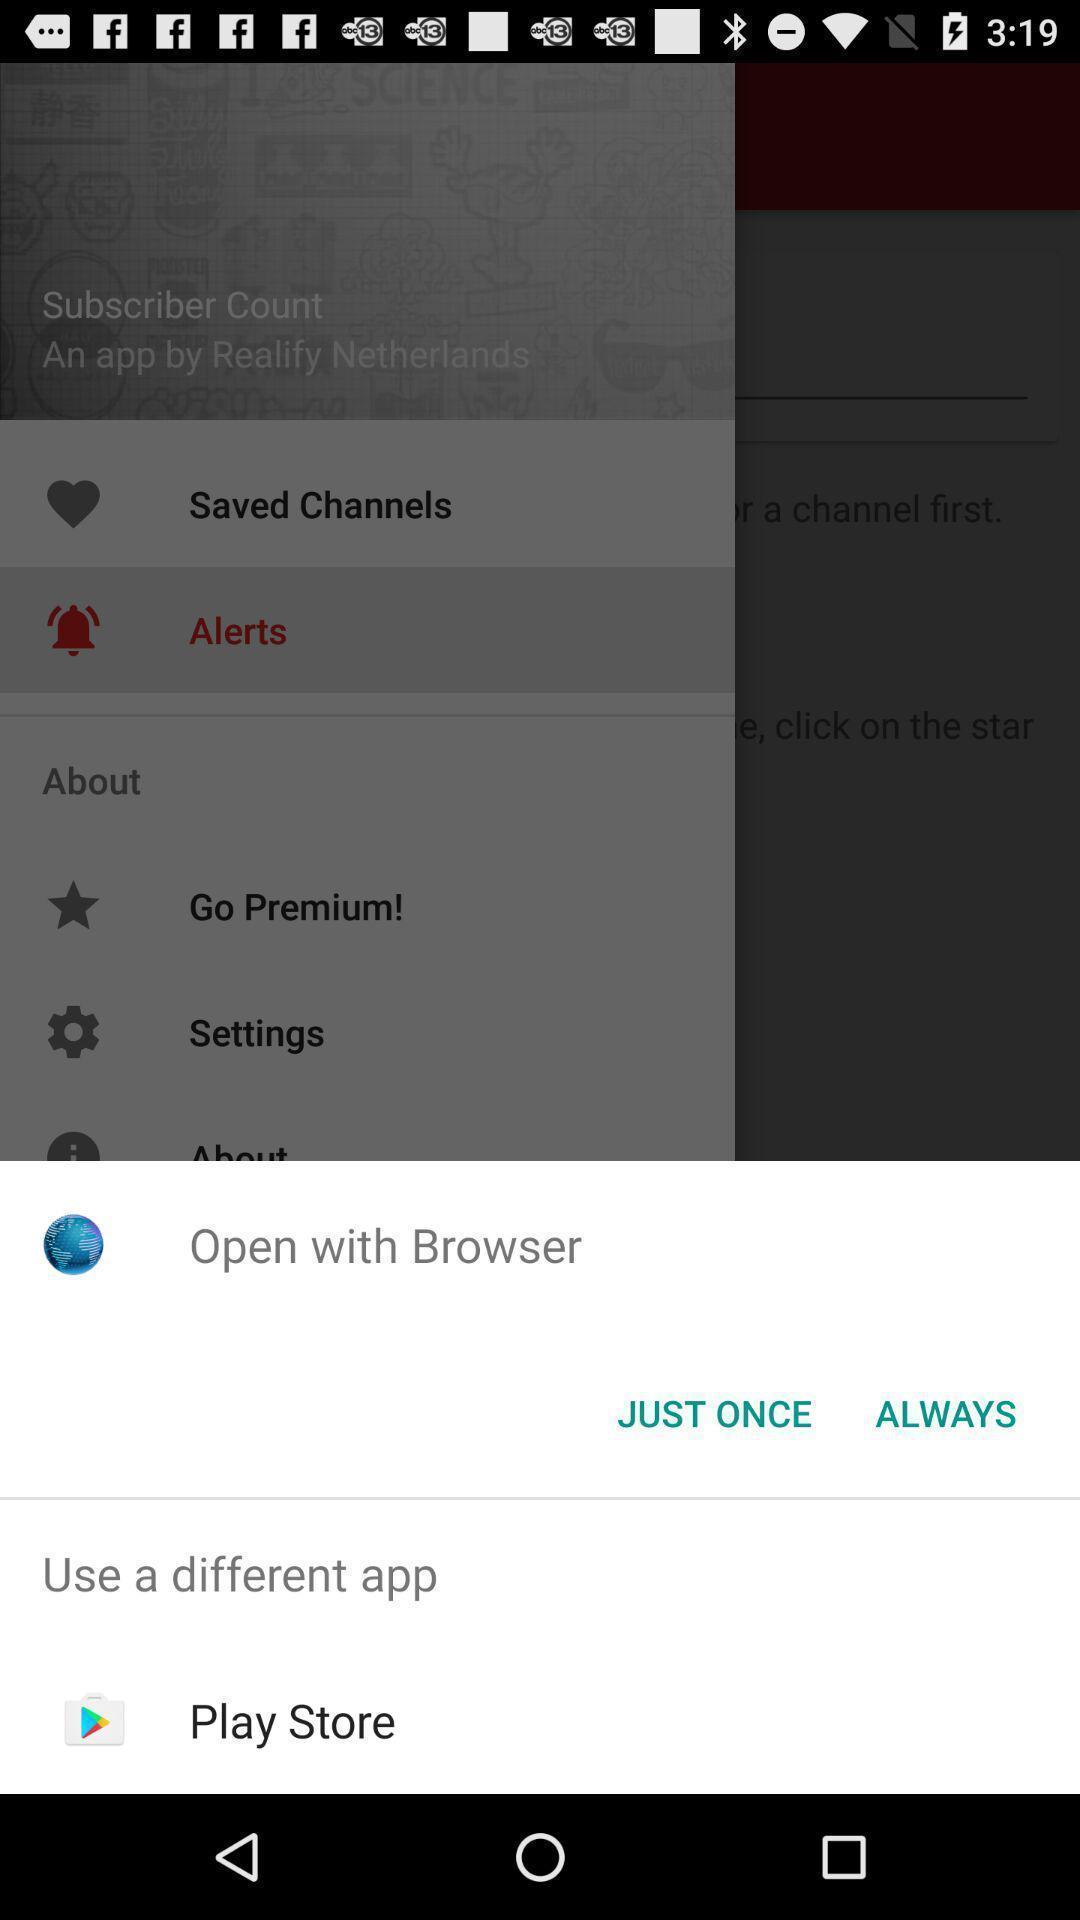Tell me what you see in this picture. Pop-up displaying to open an app. 